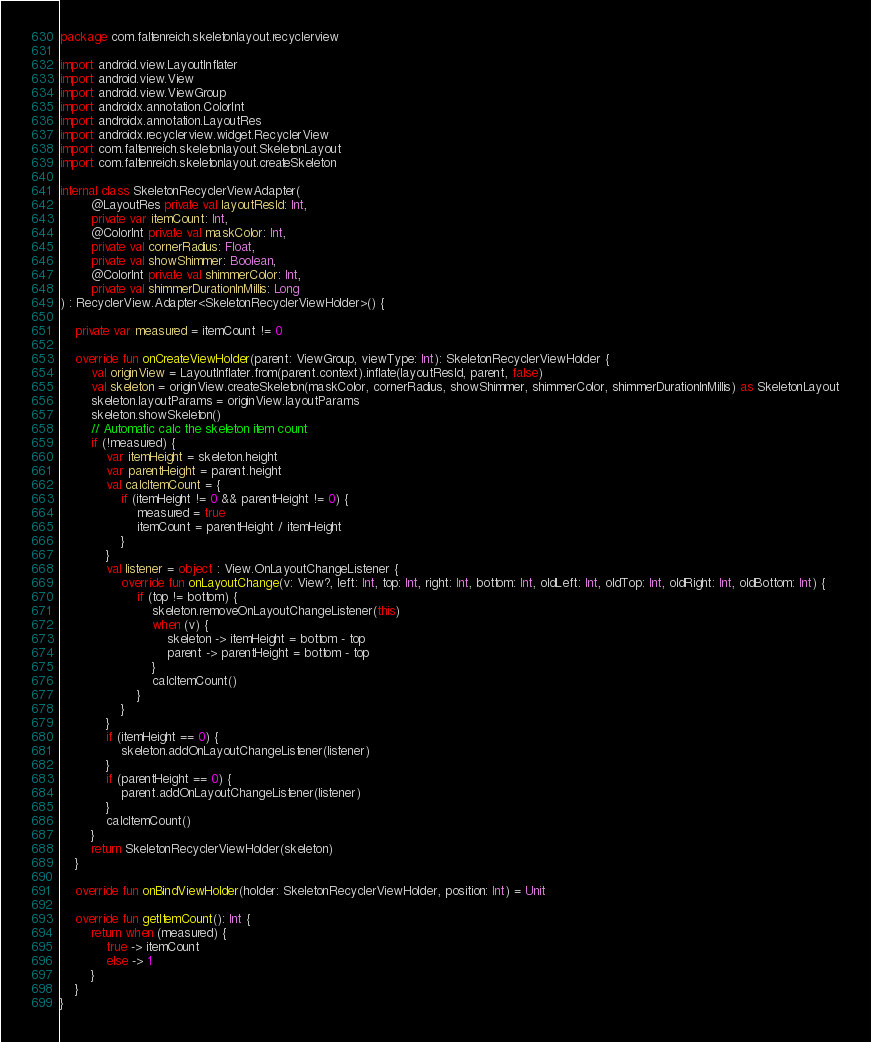<code> <loc_0><loc_0><loc_500><loc_500><_Kotlin_>package com.faltenreich.skeletonlayout.recyclerview

import android.view.LayoutInflater
import android.view.View
import android.view.ViewGroup
import androidx.annotation.ColorInt
import androidx.annotation.LayoutRes
import androidx.recyclerview.widget.RecyclerView
import com.faltenreich.skeletonlayout.SkeletonLayout
import com.faltenreich.skeletonlayout.createSkeleton

internal class SkeletonRecyclerViewAdapter(
        @LayoutRes private val layoutResId: Int,
        private var itemCount: Int,
        @ColorInt private val maskColor: Int,
        private val cornerRadius: Float,
        private val showShimmer: Boolean,
        @ColorInt private val shimmerColor: Int,
        private val shimmerDurationInMillis: Long
) : RecyclerView.Adapter<SkeletonRecyclerViewHolder>() {

    private var measured = itemCount != 0

    override fun onCreateViewHolder(parent: ViewGroup, viewType: Int): SkeletonRecyclerViewHolder {
        val originView = LayoutInflater.from(parent.context).inflate(layoutResId, parent, false)
        val skeleton = originView.createSkeleton(maskColor, cornerRadius, showShimmer, shimmerColor, shimmerDurationInMillis) as SkeletonLayout
        skeleton.layoutParams = originView.layoutParams
        skeleton.showSkeleton()
        // Automatic calc the skeleton item count
        if (!measured) {
            var itemHeight = skeleton.height
            var parentHeight = parent.height
            val calcItemCount = {
                if (itemHeight != 0 && parentHeight != 0) {
                    measured = true
                    itemCount = parentHeight / itemHeight
                }
            }
            val listener = object : View.OnLayoutChangeListener {
                override fun onLayoutChange(v: View?, left: Int, top: Int, right: Int, bottom: Int, oldLeft: Int, oldTop: Int, oldRight: Int, oldBottom: Int) {
                    if (top != bottom) {
                        skeleton.removeOnLayoutChangeListener(this)
                        when (v) {
                            skeleton -> itemHeight = bottom - top
                            parent -> parentHeight = bottom - top
                        }
                        calcItemCount()
                    }
                }
            }
            if (itemHeight == 0) {
                skeleton.addOnLayoutChangeListener(listener)
            }
            if (parentHeight == 0) {
                parent.addOnLayoutChangeListener(listener)
            }
            calcItemCount()
        }
        return SkeletonRecyclerViewHolder(skeleton)
    }

    override fun onBindViewHolder(holder: SkeletonRecyclerViewHolder, position: Int) = Unit

    override fun getItemCount(): Int {
        return when (measured) {
            true -> itemCount
            else -> 1
        }
    }
}</code> 